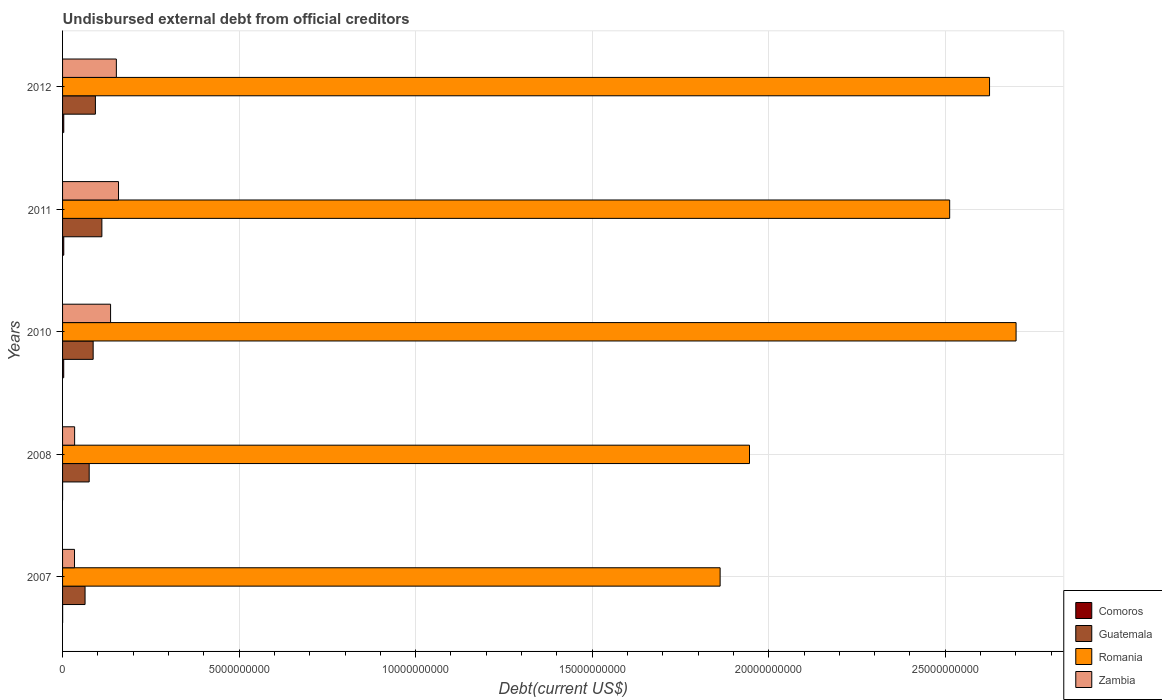How many groups of bars are there?
Offer a very short reply. 5. How many bars are there on the 2nd tick from the top?
Ensure brevity in your answer.  4. How many bars are there on the 1st tick from the bottom?
Offer a terse response. 4. In how many cases, is the number of bars for a given year not equal to the number of legend labels?
Make the answer very short. 0. What is the total debt in Zambia in 2011?
Your answer should be compact. 1.58e+09. Across all years, what is the maximum total debt in Comoros?
Give a very brief answer. 3.42e+07. Across all years, what is the minimum total debt in Guatemala?
Your response must be concise. 6.37e+08. What is the total total debt in Zambia in the graph?
Offer a very short reply. 5.15e+09. What is the difference between the total debt in Romania in 2010 and that in 2012?
Keep it short and to the point. 7.52e+08. What is the difference between the total debt in Romania in 2010 and the total debt in Zambia in 2008?
Provide a succinct answer. 2.67e+1. What is the average total debt in Romania per year?
Provide a short and direct response. 2.33e+1. In the year 2012, what is the difference between the total debt in Comoros and total debt in Romania?
Ensure brevity in your answer.  -2.62e+1. In how many years, is the total debt in Romania greater than 19000000000 US$?
Your answer should be compact. 4. What is the ratio of the total debt in Zambia in 2008 to that in 2011?
Your answer should be very brief. 0.22. What is the difference between the highest and the second highest total debt in Zambia?
Your response must be concise. 6.11e+07. What is the difference between the highest and the lowest total debt in Romania?
Give a very brief answer. 8.38e+09. In how many years, is the total debt in Romania greater than the average total debt in Romania taken over all years?
Your response must be concise. 3. Is the sum of the total debt in Romania in 2007 and 2012 greater than the maximum total debt in Comoros across all years?
Ensure brevity in your answer.  Yes. What does the 2nd bar from the top in 2012 represents?
Your answer should be compact. Romania. What does the 1st bar from the bottom in 2012 represents?
Offer a very short reply. Comoros. How many bars are there?
Provide a succinct answer. 20. Are the values on the major ticks of X-axis written in scientific E-notation?
Your answer should be very brief. No. Does the graph contain grids?
Offer a terse response. Yes. How many legend labels are there?
Keep it short and to the point. 4. How are the legend labels stacked?
Make the answer very short. Vertical. What is the title of the graph?
Ensure brevity in your answer.  Undisbursed external debt from official creditors. What is the label or title of the X-axis?
Keep it short and to the point. Debt(current US$). What is the label or title of the Y-axis?
Make the answer very short. Years. What is the Debt(current US$) of Comoros in 2007?
Your response must be concise. 1.80e+06. What is the Debt(current US$) of Guatemala in 2007?
Your answer should be very brief. 6.37e+08. What is the Debt(current US$) of Romania in 2007?
Provide a succinct answer. 1.86e+1. What is the Debt(current US$) in Zambia in 2007?
Ensure brevity in your answer.  3.38e+08. What is the Debt(current US$) of Comoros in 2008?
Provide a succinct answer. 4.97e+05. What is the Debt(current US$) of Guatemala in 2008?
Your response must be concise. 7.54e+08. What is the Debt(current US$) in Romania in 2008?
Provide a succinct answer. 1.95e+1. What is the Debt(current US$) of Zambia in 2008?
Offer a very short reply. 3.42e+08. What is the Debt(current US$) of Comoros in 2010?
Offer a terse response. 3.25e+07. What is the Debt(current US$) of Guatemala in 2010?
Keep it short and to the point. 8.66e+08. What is the Debt(current US$) in Romania in 2010?
Ensure brevity in your answer.  2.70e+1. What is the Debt(current US$) of Zambia in 2010?
Make the answer very short. 1.36e+09. What is the Debt(current US$) of Comoros in 2011?
Provide a short and direct response. 3.41e+07. What is the Debt(current US$) of Guatemala in 2011?
Provide a succinct answer. 1.11e+09. What is the Debt(current US$) of Romania in 2011?
Keep it short and to the point. 2.51e+1. What is the Debt(current US$) in Zambia in 2011?
Your response must be concise. 1.58e+09. What is the Debt(current US$) of Comoros in 2012?
Your answer should be compact. 3.42e+07. What is the Debt(current US$) in Guatemala in 2012?
Your answer should be compact. 9.30e+08. What is the Debt(current US$) of Romania in 2012?
Your answer should be compact. 2.63e+1. What is the Debt(current US$) in Zambia in 2012?
Ensure brevity in your answer.  1.52e+09. Across all years, what is the maximum Debt(current US$) of Comoros?
Your response must be concise. 3.42e+07. Across all years, what is the maximum Debt(current US$) of Guatemala?
Give a very brief answer. 1.11e+09. Across all years, what is the maximum Debt(current US$) of Romania?
Offer a very short reply. 2.70e+1. Across all years, what is the maximum Debt(current US$) of Zambia?
Offer a very short reply. 1.58e+09. Across all years, what is the minimum Debt(current US$) in Comoros?
Your response must be concise. 4.97e+05. Across all years, what is the minimum Debt(current US$) of Guatemala?
Make the answer very short. 6.37e+08. Across all years, what is the minimum Debt(current US$) in Romania?
Your answer should be very brief. 1.86e+1. Across all years, what is the minimum Debt(current US$) in Zambia?
Your response must be concise. 3.38e+08. What is the total Debt(current US$) of Comoros in the graph?
Your response must be concise. 1.03e+08. What is the total Debt(current US$) of Guatemala in the graph?
Your answer should be very brief. 4.30e+09. What is the total Debt(current US$) of Romania in the graph?
Keep it short and to the point. 1.16e+11. What is the total Debt(current US$) of Zambia in the graph?
Keep it short and to the point. 5.15e+09. What is the difference between the Debt(current US$) of Comoros in 2007 and that in 2008?
Your answer should be very brief. 1.31e+06. What is the difference between the Debt(current US$) of Guatemala in 2007 and that in 2008?
Offer a terse response. -1.17e+08. What is the difference between the Debt(current US$) of Romania in 2007 and that in 2008?
Provide a succinct answer. -8.32e+08. What is the difference between the Debt(current US$) of Zambia in 2007 and that in 2008?
Keep it short and to the point. -3.15e+06. What is the difference between the Debt(current US$) of Comoros in 2007 and that in 2010?
Keep it short and to the point. -3.07e+07. What is the difference between the Debt(current US$) of Guatemala in 2007 and that in 2010?
Offer a terse response. -2.29e+08. What is the difference between the Debt(current US$) of Romania in 2007 and that in 2010?
Your answer should be very brief. -8.38e+09. What is the difference between the Debt(current US$) in Zambia in 2007 and that in 2010?
Your answer should be very brief. -1.02e+09. What is the difference between the Debt(current US$) in Comoros in 2007 and that in 2011?
Offer a very short reply. -3.23e+07. What is the difference between the Debt(current US$) in Guatemala in 2007 and that in 2011?
Provide a short and direct response. -4.76e+08. What is the difference between the Debt(current US$) of Romania in 2007 and that in 2011?
Ensure brevity in your answer.  -6.50e+09. What is the difference between the Debt(current US$) of Zambia in 2007 and that in 2011?
Your answer should be compact. -1.25e+09. What is the difference between the Debt(current US$) in Comoros in 2007 and that in 2012?
Offer a very short reply. -3.24e+07. What is the difference between the Debt(current US$) of Guatemala in 2007 and that in 2012?
Provide a succinct answer. -2.93e+08. What is the difference between the Debt(current US$) of Romania in 2007 and that in 2012?
Ensure brevity in your answer.  -7.63e+09. What is the difference between the Debt(current US$) of Zambia in 2007 and that in 2012?
Offer a terse response. -1.18e+09. What is the difference between the Debt(current US$) of Comoros in 2008 and that in 2010?
Provide a short and direct response. -3.20e+07. What is the difference between the Debt(current US$) in Guatemala in 2008 and that in 2010?
Your answer should be very brief. -1.12e+08. What is the difference between the Debt(current US$) in Romania in 2008 and that in 2010?
Your answer should be compact. -7.55e+09. What is the difference between the Debt(current US$) of Zambia in 2008 and that in 2010?
Give a very brief answer. -1.02e+09. What is the difference between the Debt(current US$) of Comoros in 2008 and that in 2011?
Make the answer very short. -3.36e+07. What is the difference between the Debt(current US$) of Guatemala in 2008 and that in 2011?
Provide a succinct answer. -3.59e+08. What is the difference between the Debt(current US$) in Romania in 2008 and that in 2011?
Provide a succinct answer. -5.67e+09. What is the difference between the Debt(current US$) in Zambia in 2008 and that in 2011?
Your response must be concise. -1.24e+09. What is the difference between the Debt(current US$) in Comoros in 2008 and that in 2012?
Your response must be concise. -3.37e+07. What is the difference between the Debt(current US$) of Guatemala in 2008 and that in 2012?
Your response must be concise. -1.76e+08. What is the difference between the Debt(current US$) in Romania in 2008 and that in 2012?
Provide a succinct answer. -6.80e+09. What is the difference between the Debt(current US$) in Zambia in 2008 and that in 2012?
Your answer should be compact. -1.18e+09. What is the difference between the Debt(current US$) in Comoros in 2010 and that in 2011?
Ensure brevity in your answer.  -1.66e+06. What is the difference between the Debt(current US$) of Guatemala in 2010 and that in 2011?
Your response must be concise. -2.47e+08. What is the difference between the Debt(current US$) in Romania in 2010 and that in 2011?
Keep it short and to the point. 1.88e+09. What is the difference between the Debt(current US$) in Zambia in 2010 and that in 2011?
Offer a very short reply. -2.25e+08. What is the difference between the Debt(current US$) of Comoros in 2010 and that in 2012?
Offer a very short reply. -1.72e+06. What is the difference between the Debt(current US$) of Guatemala in 2010 and that in 2012?
Keep it short and to the point. -6.38e+07. What is the difference between the Debt(current US$) in Romania in 2010 and that in 2012?
Provide a short and direct response. 7.52e+08. What is the difference between the Debt(current US$) of Zambia in 2010 and that in 2012?
Make the answer very short. -1.64e+08. What is the difference between the Debt(current US$) in Comoros in 2011 and that in 2012?
Keep it short and to the point. -6.10e+04. What is the difference between the Debt(current US$) in Guatemala in 2011 and that in 2012?
Give a very brief answer. 1.83e+08. What is the difference between the Debt(current US$) of Romania in 2011 and that in 2012?
Give a very brief answer. -1.13e+09. What is the difference between the Debt(current US$) in Zambia in 2011 and that in 2012?
Provide a succinct answer. 6.11e+07. What is the difference between the Debt(current US$) of Comoros in 2007 and the Debt(current US$) of Guatemala in 2008?
Keep it short and to the point. -7.52e+08. What is the difference between the Debt(current US$) in Comoros in 2007 and the Debt(current US$) in Romania in 2008?
Your answer should be compact. -1.95e+1. What is the difference between the Debt(current US$) in Comoros in 2007 and the Debt(current US$) in Zambia in 2008?
Your answer should be compact. -3.40e+08. What is the difference between the Debt(current US$) in Guatemala in 2007 and the Debt(current US$) in Romania in 2008?
Provide a short and direct response. -1.88e+1. What is the difference between the Debt(current US$) in Guatemala in 2007 and the Debt(current US$) in Zambia in 2008?
Provide a succinct answer. 2.96e+08. What is the difference between the Debt(current US$) in Romania in 2007 and the Debt(current US$) in Zambia in 2008?
Give a very brief answer. 1.83e+1. What is the difference between the Debt(current US$) of Comoros in 2007 and the Debt(current US$) of Guatemala in 2010?
Your answer should be compact. -8.65e+08. What is the difference between the Debt(current US$) of Comoros in 2007 and the Debt(current US$) of Romania in 2010?
Your response must be concise. -2.70e+1. What is the difference between the Debt(current US$) of Comoros in 2007 and the Debt(current US$) of Zambia in 2010?
Offer a very short reply. -1.36e+09. What is the difference between the Debt(current US$) in Guatemala in 2007 and the Debt(current US$) in Romania in 2010?
Your answer should be compact. -2.64e+1. What is the difference between the Debt(current US$) in Guatemala in 2007 and the Debt(current US$) in Zambia in 2010?
Give a very brief answer. -7.23e+08. What is the difference between the Debt(current US$) of Romania in 2007 and the Debt(current US$) of Zambia in 2010?
Provide a short and direct response. 1.73e+1. What is the difference between the Debt(current US$) of Comoros in 2007 and the Debt(current US$) of Guatemala in 2011?
Make the answer very short. -1.11e+09. What is the difference between the Debt(current US$) in Comoros in 2007 and the Debt(current US$) in Romania in 2011?
Offer a very short reply. -2.51e+1. What is the difference between the Debt(current US$) in Comoros in 2007 and the Debt(current US$) in Zambia in 2011?
Your answer should be very brief. -1.58e+09. What is the difference between the Debt(current US$) of Guatemala in 2007 and the Debt(current US$) of Romania in 2011?
Offer a terse response. -2.45e+1. What is the difference between the Debt(current US$) of Guatemala in 2007 and the Debt(current US$) of Zambia in 2011?
Your answer should be compact. -9.47e+08. What is the difference between the Debt(current US$) in Romania in 2007 and the Debt(current US$) in Zambia in 2011?
Ensure brevity in your answer.  1.70e+1. What is the difference between the Debt(current US$) of Comoros in 2007 and the Debt(current US$) of Guatemala in 2012?
Offer a very short reply. -9.28e+08. What is the difference between the Debt(current US$) in Comoros in 2007 and the Debt(current US$) in Romania in 2012?
Your response must be concise. -2.63e+1. What is the difference between the Debt(current US$) of Comoros in 2007 and the Debt(current US$) of Zambia in 2012?
Ensure brevity in your answer.  -1.52e+09. What is the difference between the Debt(current US$) of Guatemala in 2007 and the Debt(current US$) of Romania in 2012?
Your answer should be compact. -2.56e+1. What is the difference between the Debt(current US$) of Guatemala in 2007 and the Debt(current US$) of Zambia in 2012?
Offer a very short reply. -8.86e+08. What is the difference between the Debt(current US$) in Romania in 2007 and the Debt(current US$) in Zambia in 2012?
Ensure brevity in your answer.  1.71e+1. What is the difference between the Debt(current US$) in Comoros in 2008 and the Debt(current US$) in Guatemala in 2010?
Offer a terse response. -8.66e+08. What is the difference between the Debt(current US$) of Comoros in 2008 and the Debt(current US$) of Romania in 2010?
Ensure brevity in your answer.  -2.70e+1. What is the difference between the Debt(current US$) in Comoros in 2008 and the Debt(current US$) in Zambia in 2010?
Your response must be concise. -1.36e+09. What is the difference between the Debt(current US$) in Guatemala in 2008 and the Debt(current US$) in Romania in 2010?
Provide a short and direct response. -2.63e+1. What is the difference between the Debt(current US$) of Guatemala in 2008 and the Debt(current US$) of Zambia in 2010?
Provide a short and direct response. -6.06e+08. What is the difference between the Debt(current US$) in Romania in 2008 and the Debt(current US$) in Zambia in 2010?
Provide a short and direct response. 1.81e+1. What is the difference between the Debt(current US$) in Comoros in 2008 and the Debt(current US$) in Guatemala in 2011?
Keep it short and to the point. -1.11e+09. What is the difference between the Debt(current US$) in Comoros in 2008 and the Debt(current US$) in Romania in 2011?
Give a very brief answer. -2.51e+1. What is the difference between the Debt(current US$) in Comoros in 2008 and the Debt(current US$) in Zambia in 2011?
Give a very brief answer. -1.58e+09. What is the difference between the Debt(current US$) of Guatemala in 2008 and the Debt(current US$) of Romania in 2011?
Make the answer very short. -2.44e+1. What is the difference between the Debt(current US$) of Guatemala in 2008 and the Debt(current US$) of Zambia in 2011?
Your answer should be compact. -8.30e+08. What is the difference between the Debt(current US$) in Romania in 2008 and the Debt(current US$) in Zambia in 2011?
Offer a very short reply. 1.79e+1. What is the difference between the Debt(current US$) of Comoros in 2008 and the Debt(current US$) of Guatemala in 2012?
Provide a succinct answer. -9.30e+08. What is the difference between the Debt(current US$) of Comoros in 2008 and the Debt(current US$) of Romania in 2012?
Provide a succinct answer. -2.63e+1. What is the difference between the Debt(current US$) in Comoros in 2008 and the Debt(current US$) in Zambia in 2012?
Your answer should be very brief. -1.52e+09. What is the difference between the Debt(current US$) of Guatemala in 2008 and the Debt(current US$) of Romania in 2012?
Give a very brief answer. -2.55e+1. What is the difference between the Debt(current US$) in Guatemala in 2008 and the Debt(current US$) in Zambia in 2012?
Your answer should be compact. -7.69e+08. What is the difference between the Debt(current US$) in Romania in 2008 and the Debt(current US$) in Zambia in 2012?
Offer a very short reply. 1.79e+1. What is the difference between the Debt(current US$) of Comoros in 2010 and the Debt(current US$) of Guatemala in 2011?
Ensure brevity in your answer.  -1.08e+09. What is the difference between the Debt(current US$) in Comoros in 2010 and the Debt(current US$) in Romania in 2011?
Offer a terse response. -2.51e+1. What is the difference between the Debt(current US$) in Comoros in 2010 and the Debt(current US$) in Zambia in 2011?
Provide a short and direct response. -1.55e+09. What is the difference between the Debt(current US$) of Guatemala in 2010 and the Debt(current US$) of Romania in 2011?
Give a very brief answer. -2.43e+1. What is the difference between the Debt(current US$) in Guatemala in 2010 and the Debt(current US$) in Zambia in 2011?
Offer a very short reply. -7.18e+08. What is the difference between the Debt(current US$) of Romania in 2010 and the Debt(current US$) of Zambia in 2011?
Your answer should be compact. 2.54e+1. What is the difference between the Debt(current US$) in Comoros in 2010 and the Debt(current US$) in Guatemala in 2012?
Provide a short and direct response. -8.98e+08. What is the difference between the Debt(current US$) in Comoros in 2010 and the Debt(current US$) in Romania in 2012?
Offer a terse response. -2.62e+1. What is the difference between the Debt(current US$) of Comoros in 2010 and the Debt(current US$) of Zambia in 2012?
Offer a terse response. -1.49e+09. What is the difference between the Debt(current US$) of Guatemala in 2010 and the Debt(current US$) of Romania in 2012?
Make the answer very short. -2.54e+1. What is the difference between the Debt(current US$) of Guatemala in 2010 and the Debt(current US$) of Zambia in 2012?
Your answer should be very brief. -6.57e+08. What is the difference between the Debt(current US$) in Romania in 2010 and the Debt(current US$) in Zambia in 2012?
Make the answer very short. 2.55e+1. What is the difference between the Debt(current US$) in Comoros in 2011 and the Debt(current US$) in Guatemala in 2012?
Offer a terse response. -8.96e+08. What is the difference between the Debt(current US$) of Comoros in 2011 and the Debt(current US$) of Romania in 2012?
Provide a short and direct response. -2.62e+1. What is the difference between the Debt(current US$) in Comoros in 2011 and the Debt(current US$) in Zambia in 2012?
Ensure brevity in your answer.  -1.49e+09. What is the difference between the Debt(current US$) in Guatemala in 2011 and the Debt(current US$) in Romania in 2012?
Make the answer very short. -2.51e+1. What is the difference between the Debt(current US$) of Guatemala in 2011 and the Debt(current US$) of Zambia in 2012?
Your answer should be compact. -4.10e+08. What is the difference between the Debt(current US$) of Romania in 2011 and the Debt(current US$) of Zambia in 2012?
Ensure brevity in your answer.  2.36e+1. What is the average Debt(current US$) of Comoros per year?
Ensure brevity in your answer.  2.06e+07. What is the average Debt(current US$) in Guatemala per year?
Ensure brevity in your answer.  8.60e+08. What is the average Debt(current US$) in Romania per year?
Your answer should be compact. 2.33e+1. What is the average Debt(current US$) of Zambia per year?
Your answer should be compact. 1.03e+09. In the year 2007, what is the difference between the Debt(current US$) in Comoros and Debt(current US$) in Guatemala?
Make the answer very short. -6.35e+08. In the year 2007, what is the difference between the Debt(current US$) in Comoros and Debt(current US$) in Romania?
Keep it short and to the point. -1.86e+1. In the year 2007, what is the difference between the Debt(current US$) of Comoros and Debt(current US$) of Zambia?
Ensure brevity in your answer.  -3.37e+08. In the year 2007, what is the difference between the Debt(current US$) in Guatemala and Debt(current US$) in Romania?
Your answer should be compact. -1.80e+1. In the year 2007, what is the difference between the Debt(current US$) in Guatemala and Debt(current US$) in Zambia?
Your answer should be compact. 2.99e+08. In the year 2007, what is the difference between the Debt(current US$) of Romania and Debt(current US$) of Zambia?
Offer a very short reply. 1.83e+1. In the year 2008, what is the difference between the Debt(current US$) of Comoros and Debt(current US$) of Guatemala?
Ensure brevity in your answer.  -7.54e+08. In the year 2008, what is the difference between the Debt(current US$) in Comoros and Debt(current US$) in Romania?
Your response must be concise. -1.95e+1. In the year 2008, what is the difference between the Debt(current US$) of Comoros and Debt(current US$) of Zambia?
Keep it short and to the point. -3.41e+08. In the year 2008, what is the difference between the Debt(current US$) in Guatemala and Debt(current US$) in Romania?
Provide a short and direct response. -1.87e+1. In the year 2008, what is the difference between the Debt(current US$) in Guatemala and Debt(current US$) in Zambia?
Keep it short and to the point. 4.12e+08. In the year 2008, what is the difference between the Debt(current US$) of Romania and Debt(current US$) of Zambia?
Make the answer very short. 1.91e+1. In the year 2010, what is the difference between the Debt(current US$) of Comoros and Debt(current US$) of Guatemala?
Make the answer very short. -8.34e+08. In the year 2010, what is the difference between the Debt(current US$) in Comoros and Debt(current US$) in Romania?
Your answer should be very brief. -2.70e+1. In the year 2010, what is the difference between the Debt(current US$) of Comoros and Debt(current US$) of Zambia?
Your response must be concise. -1.33e+09. In the year 2010, what is the difference between the Debt(current US$) of Guatemala and Debt(current US$) of Romania?
Your answer should be very brief. -2.61e+1. In the year 2010, what is the difference between the Debt(current US$) of Guatemala and Debt(current US$) of Zambia?
Provide a short and direct response. -4.93e+08. In the year 2010, what is the difference between the Debt(current US$) in Romania and Debt(current US$) in Zambia?
Make the answer very short. 2.56e+1. In the year 2011, what is the difference between the Debt(current US$) in Comoros and Debt(current US$) in Guatemala?
Provide a succinct answer. -1.08e+09. In the year 2011, what is the difference between the Debt(current US$) of Comoros and Debt(current US$) of Romania?
Make the answer very short. -2.51e+1. In the year 2011, what is the difference between the Debt(current US$) in Comoros and Debt(current US$) in Zambia?
Provide a short and direct response. -1.55e+09. In the year 2011, what is the difference between the Debt(current US$) in Guatemala and Debt(current US$) in Romania?
Offer a terse response. -2.40e+1. In the year 2011, what is the difference between the Debt(current US$) of Guatemala and Debt(current US$) of Zambia?
Provide a succinct answer. -4.71e+08. In the year 2011, what is the difference between the Debt(current US$) of Romania and Debt(current US$) of Zambia?
Give a very brief answer. 2.35e+1. In the year 2012, what is the difference between the Debt(current US$) of Comoros and Debt(current US$) of Guatemala?
Your response must be concise. -8.96e+08. In the year 2012, what is the difference between the Debt(current US$) of Comoros and Debt(current US$) of Romania?
Your answer should be compact. -2.62e+1. In the year 2012, what is the difference between the Debt(current US$) in Comoros and Debt(current US$) in Zambia?
Your answer should be compact. -1.49e+09. In the year 2012, what is the difference between the Debt(current US$) of Guatemala and Debt(current US$) of Romania?
Give a very brief answer. -2.53e+1. In the year 2012, what is the difference between the Debt(current US$) of Guatemala and Debt(current US$) of Zambia?
Make the answer very short. -5.93e+08. In the year 2012, what is the difference between the Debt(current US$) in Romania and Debt(current US$) in Zambia?
Ensure brevity in your answer.  2.47e+1. What is the ratio of the Debt(current US$) of Comoros in 2007 to that in 2008?
Offer a terse response. 3.63. What is the ratio of the Debt(current US$) of Guatemala in 2007 to that in 2008?
Provide a succinct answer. 0.85. What is the ratio of the Debt(current US$) in Romania in 2007 to that in 2008?
Give a very brief answer. 0.96. What is the ratio of the Debt(current US$) of Zambia in 2007 to that in 2008?
Your answer should be compact. 0.99. What is the ratio of the Debt(current US$) of Comoros in 2007 to that in 2010?
Ensure brevity in your answer.  0.06. What is the ratio of the Debt(current US$) in Guatemala in 2007 to that in 2010?
Provide a succinct answer. 0.74. What is the ratio of the Debt(current US$) in Romania in 2007 to that in 2010?
Ensure brevity in your answer.  0.69. What is the ratio of the Debt(current US$) of Zambia in 2007 to that in 2010?
Make the answer very short. 0.25. What is the ratio of the Debt(current US$) of Comoros in 2007 to that in 2011?
Ensure brevity in your answer.  0.05. What is the ratio of the Debt(current US$) of Guatemala in 2007 to that in 2011?
Make the answer very short. 0.57. What is the ratio of the Debt(current US$) of Romania in 2007 to that in 2011?
Make the answer very short. 0.74. What is the ratio of the Debt(current US$) of Zambia in 2007 to that in 2011?
Offer a terse response. 0.21. What is the ratio of the Debt(current US$) in Comoros in 2007 to that in 2012?
Provide a short and direct response. 0.05. What is the ratio of the Debt(current US$) of Guatemala in 2007 to that in 2012?
Offer a very short reply. 0.69. What is the ratio of the Debt(current US$) in Romania in 2007 to that in 2012?
Provide a short and direct response. 0.71. What is the ratio of the Debt(current US$) of Zambia in 2007 to that in 2012?
Your response must be concise. 0.22. What is the ratio of the Debt(current US$) of Comoros in 2008 to that in 2010?
Keep it short and to the point. 0.02. What is the ratio of the Debt(current US$) of Guatemala in 2008 to that in 2010?
Your response must be concise. 0.87. What is the ratio of the Debt(current US$) in Romania in 2008 to that in 2010?
Keep it short and to the point. 0.72. What is the ratio of the Debt(current US$) in Zambia in 2008 to that in 2010?
Give a very brief answer. 0.25. What is the ratio of the Debt(current US$) in Comoros in 2008 to that in 2011?
Your answer should be very brief. 0.01. What is the ratio of the Debt(current US$) in Guatemala in 2008 to that in 2011?
Offer a very short reply. 0.68. What is the ratio of the Debt(current US$) in Romania in 2008 to that in 2011?
Your answer should be compact. 0.77. What is the ratio of the Debt(current US$) in Zambia in 2008 to that in 2011?
Ensure brevity in your answer.  0.22. What is the ratio of the Debt(current US$) of Comoros in 2008 to that in 2012?
Provide a short and direct response. 0.01. What is the ratio of the Debt(current US$) in Guatemala in 2008 to that in 2012?
Provide a succinct answer. 0.81. What is the ratio of the Debt(current US$) of Romania in 2008 to that in 2012?
Ensure brevity in your answer.  0.74. What is the ratio of the Debt(current US$) of Zambia in 2008 to that in 2012?
Give a very brief answer. 0.22. What is the ratio of the Debt(current US$) of Comoros in 2010 to that in 2011?
Give a very brief answer. 0.95. What is the ratio of the Debt(current US$) in Guatemala in 2010 to that in 2011?
Give a very brief answer. 0.78. What is the ratio of the Debt(current US$) of Romania in 2010 to that in 2011?
Offer a terse response. 1.07. What is the ratio of the Debt(current US$) of Zambia in 2010 to that in 2011?
Provide a succinct answer. 0.86. What is the ratio of the Debt(current US$) of Comoros in 2010 to that in 2012?
Offer a very short reply. 0.95. What is the ratio of the Debt(current US$) in Guatemala in 2010 to that in 2012?
Provide a short and direct response. 0.93. What is the ratio of the Debt(current US$) in Romania in 2010 to that in 2012?
Ensure brevity in your answer.  1.03. What is the ratio of the Debt(current US$) in Zambia in 2010 to that in 2012?
Your answer should be compact. 0.89. What is the ratio of the Debt(current US$) in Comoros in 2011 to that in 2012?
Ensure brevity in your answer.  1. What is the ratio of the Debt(current US$) of Guatemala in 2011 to that in 2012?
Give a very brief answer. 1.2. What is the ratio of the Debt(current US$) in Romania in 2011 to that in 2012?
Keep it short and to the point. 0.96. What is the ratio of the Debt(current US$) in Zambia in 2011 to that in 2012?
Ensure brevity in your answer.  1.04. What is the difference between the highest and the second highest Debt(current US$) in Comoros?
Provide a short and direct response. 6.10e+04. What is the difference between the highest and the second highest Debt(current US$) in Guatemala?
Make the answer very short. 1.83e+08. What is the difference between the highest and the second highest Debt(current US$) of Romania?
Give a very brief answer. 7.52e+08. What is the difference between the highest and the second highest Debt(current US$) in Zambia?
Give a very brief answer. 6.11e+07. What is the difference between the highest and the lowest Debt(current US$) in Comoros?
Your response must be concise. 3.37e+07. What is the difference between the highest and the lowest Debt(current US$) of Guatemala?
Provide a succinct answer. 4.76e+08. What is the difference between the highest and the lowest Debt(current US$) of Romania?
Your answer should be very brief. 8.38e+09. What is the difference between the highest and the lowest Debt(current US$) in Zambia?
Ensure brevity in your answer.  1.25e+09. 